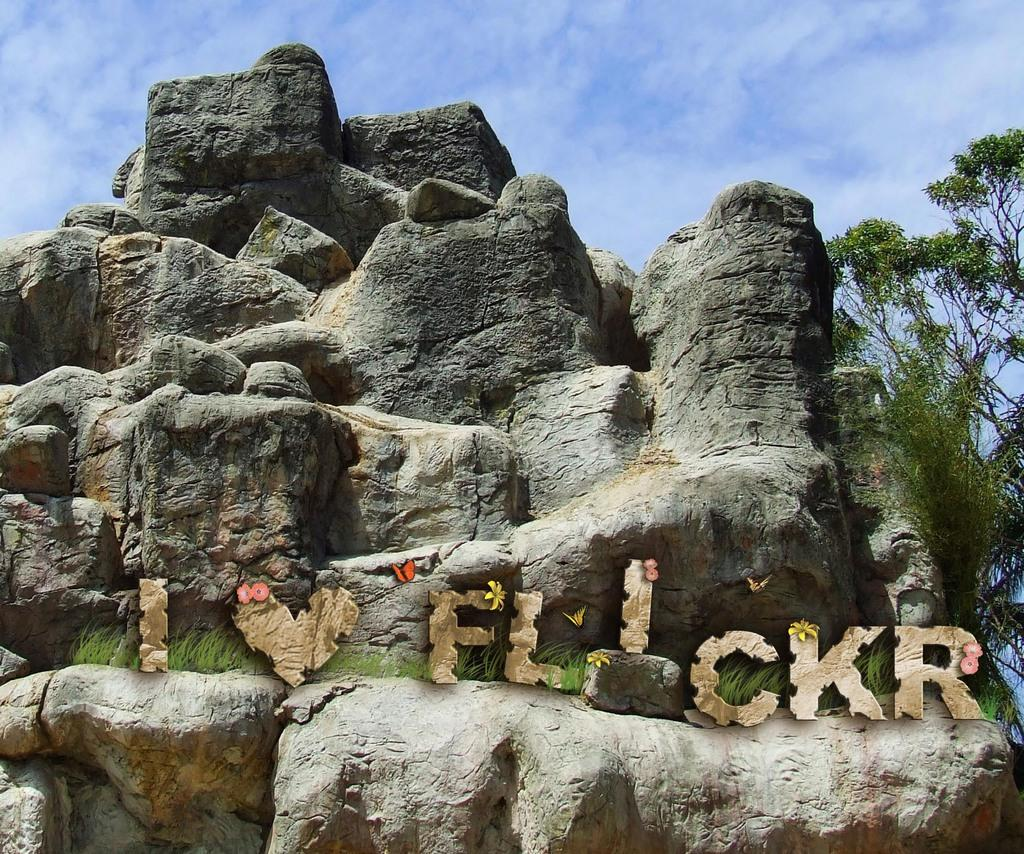What is the main subject in the image? There is a rock in the image. Are there any other objects or features near the rock? Yes, there is a tree on the side of the rock. What is written or depicted on the rock? There is animated text on the rock. How would you describe the sky in the image? The sky is blue and cloudy in the image. How many chairs are visible in the image? There are no chairs present in the image. What event is being celebrated in the image? There is no event being celebrated in the image; it features a rock, a tree, animated text, and a blue and cloudy sky. 